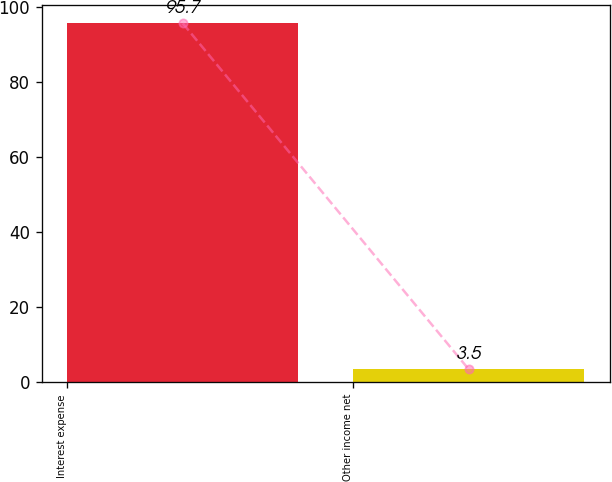Convert chart. <chart><loc_0><loc_0><loc_500><loc_500><bar_chart><fcel>Interest expense<fcel>Other income net<nl><fcel>95.7<fcel>3.5<nl></chart> 